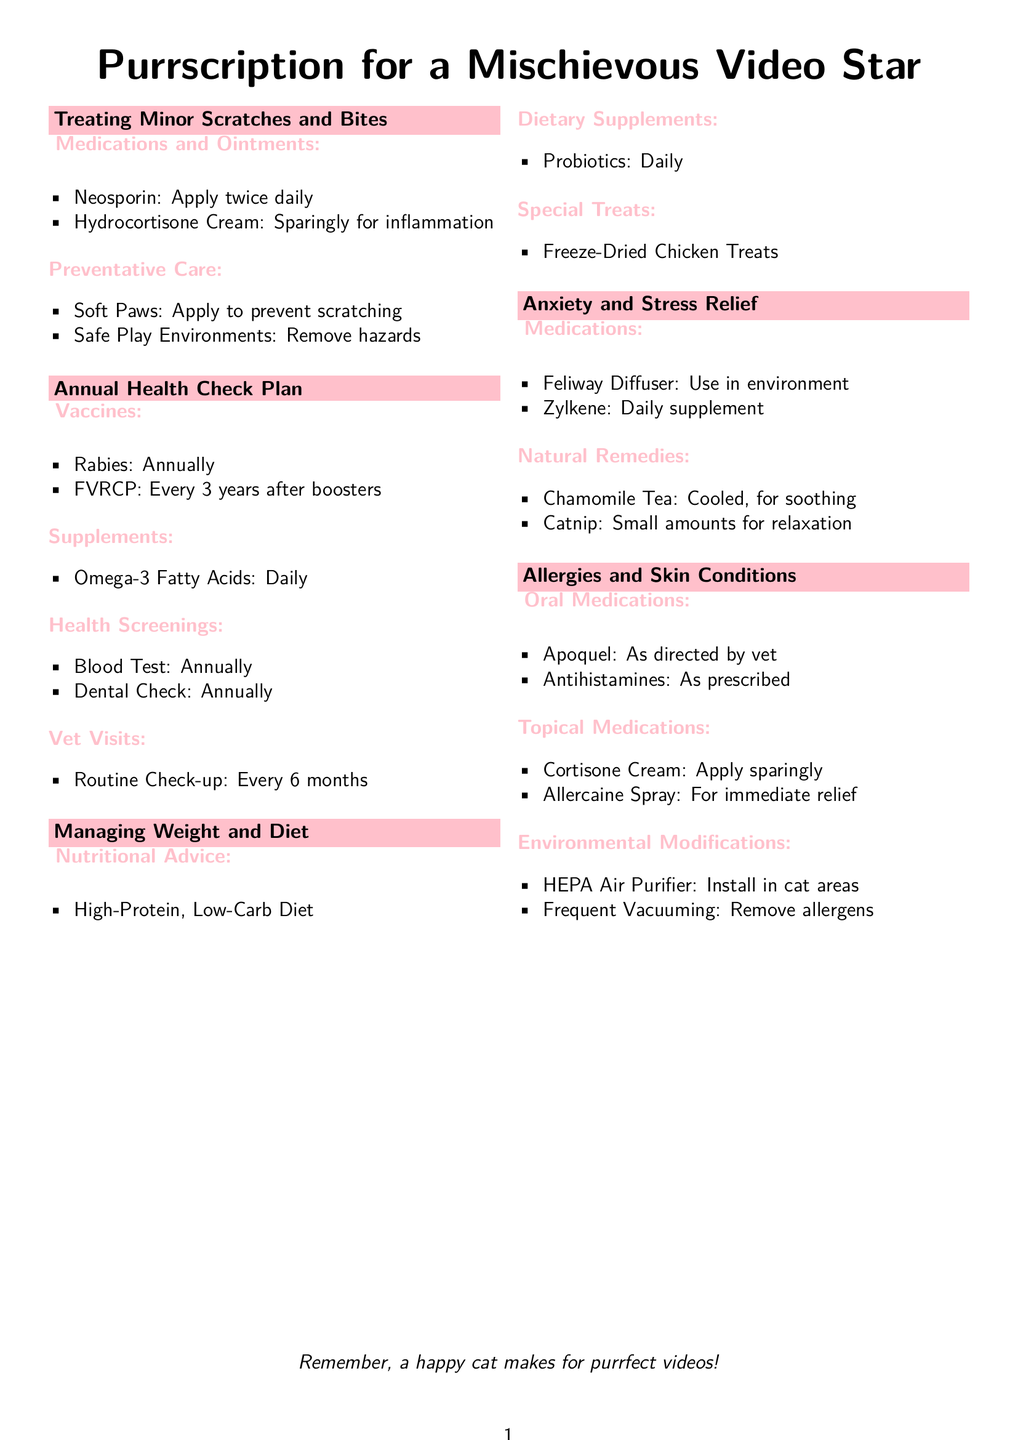What medications should be applied for minor scratches? The medications listed for treating minor scratches are Neosporin and Hydrocortisone Cream.
Answer: Neosporin, Hydrocortisone Cream How often should the rabies vaccine be administered? The document states that the rabies vaccine should be administered annually.
Answer: Annually What dietary supplement is recommended daily for weight management? The document mentions Omega-3 Fatty Acids as a daily supplement for weight management.
Answer: Omega-3 Fatty Acids What calming aid is suggested in the anxiety relief section? The calming aid mentioned for anxiety relief is the Feliway Diffuser.
Answer: Feliway Diffuser Which oral medication is recommended for allergies? Apoquel is listed as an oral medication recommended for allergies.
Answer: Apoquel What is the frequency of routine vet check-ups? The document states that routine check-ups should occur every 6 months.
Answer: Every 6 months What type of diet is prescribed for managing weight? The document advises a high-protein, low-carb diet for managing weight.
Answer: High-Protein, Low-Carb Diet What natural remedy is suggested for relaxation? Chamomile Tea is suggested as a natural remedy for relaxation.
Answer: Chamomile Tea What should be installed to help with environmental allergies? The document mentions installing a HEPA Air Purifier to help with environmental allergies.
Answer: HEPA Air Purifier 